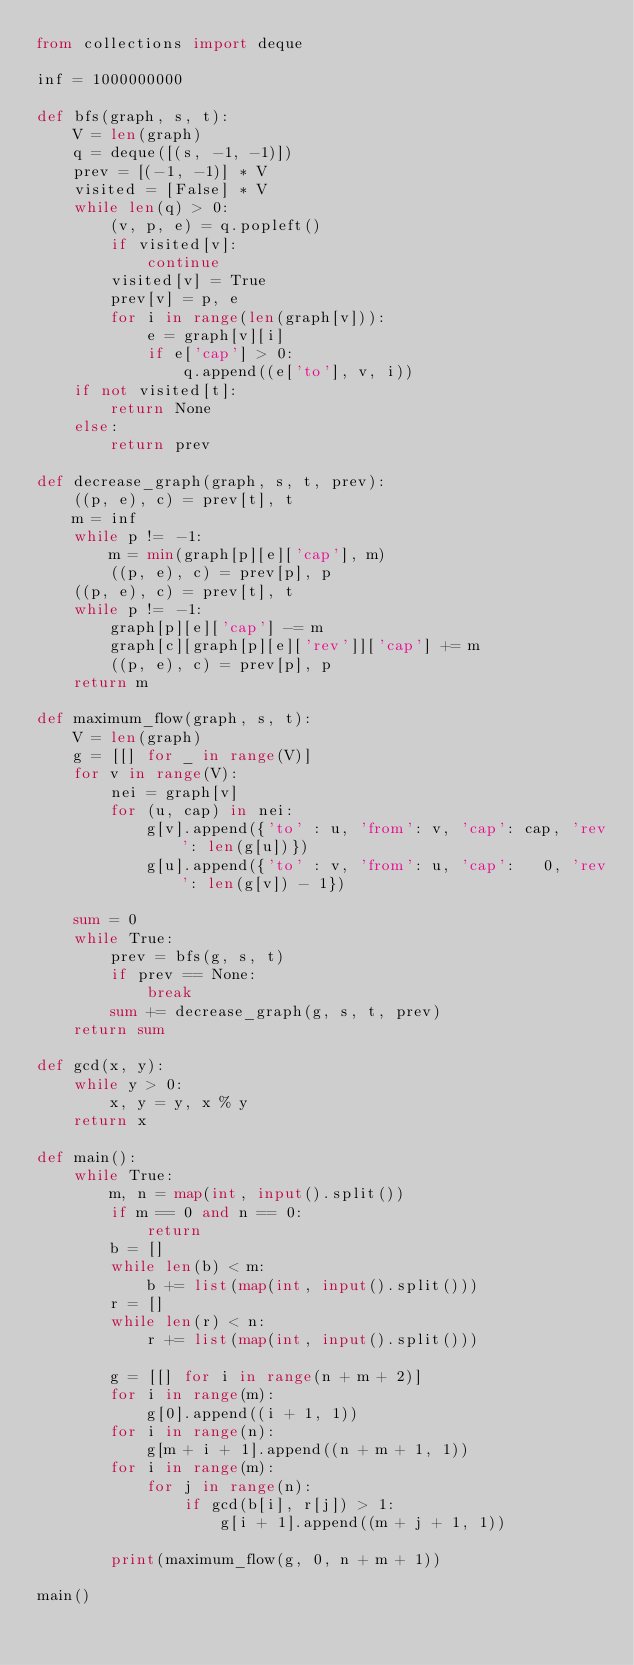<code> <loc_0><loc_0><loc_500><loc_500><_Python_>from collections import deque

inf = 1000000000

def bfs(graph, s, t):
    V = len(graph)
    q = deque([(s, -1, -1)])
    prev = [(-1, -1)] * V
    visited = [False] * V
    while len(q) > 0:
        (v, p, e) = q.popleft()
        if visited[v]:
            continue
        visited[v] = True
        prev[v] = p, e
        for i in range(len(graph[v])):
            e = graph[v][i]
            if e['cap'] > 0:
                q.append((e['to'], v, i))
    if not visited[t]:
        return None
    else:
        return prev

def decrease_graph(graph, s, t, prev):
    ((p, e), c) = prev[t], t
    m = inf
    while p != -1:
        m = min(graph[p][e]['cap'], m)
        ((p, e), c) = prev[p], p
    ((p, e), c) = prev[t], t
    while p != -1:
        graph[p][e]['cap'] -= m
        graph[c][graph[p][e]['rev']]['cap'] += m
        ((p, e), c) = prev[p], p
    return m

def maximum_flow(graph, s, t):
    V = len(graph)
    g = [[] for _ in range(V)]
    for v in range(V):
        nei = graph[v]
        for (u, cap) in nei:
            g[v].append({'to' : u, 'from': v, 'cap': cap, 'rev': len(g[u])})
            g[u].append({'to' : v, 'from': u, 'cap':   0, 'rev': len(g[v]) - 1})
    
    sum = 0
    while True:
        prev = bfs(g, s, t)
        if prev == None:
            break
        sum += decrease_graph(g, s, t, prev)
    return sum

def gcd(x, y):
    while y > 0:
        x, y = y, x % y
    return x

def main():
    while True:
        m, n = map(int, input().split())
        if m == 0 and n == 0:
            return
        b = []
        while len(b) < m:
            b += list(map(int, input().split()))
        r = []
        while len(r) < n:
            r += list(map(int, input().split()))
        
        g = [[] for i in range(n + m + 2)]
        for i in range(m):
            g[0].append((i + 1, 1))
        for i in range(n):
            g[m + i + 1].append((n + m + 1, 1))
        for i in range(m):
            for j in range(n):
                if gcd(b[i], r[j]) > 1:
                    g[i + 1].append((m + j + 1, 1))

        print(maximum_flow(g, 0, n + m + 1))
        
main()</code> 